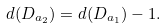Convert formula to latex. <formula><loc_0><loc_0><loc_500><loc_500>d ( D _ { a _ { 2 } } ) = d ( D _ { a _ { 1 } } ) - 1 .</formula> 